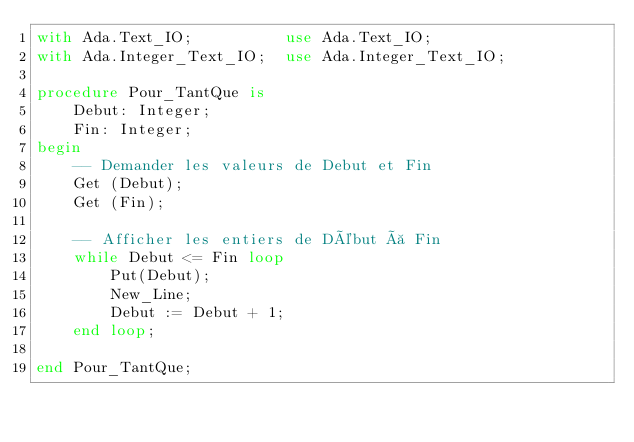<code> <loc_0><loc_0><loc_500><loc_500><_Ada_>with Ada.Text_IO;          use Ada.Text_IO;
with Ada.Integer_Text_IO;  use Ada.Integer_Text_IO;

procedure Pour_TantQue is
    Debut: Integer;
    Fin: Integer;
begin
	-- Demander les valeurs de Debut et Fin
	Get (Debut);
	Get (Fin);

	-- Afficher les entiers de Début à Fin
    while Debut <= Fin loop
        Put(Debut);
		New_Line;
        Debut := Debut + 1;
    end loop;

end Pour_TantQue;
</code> 